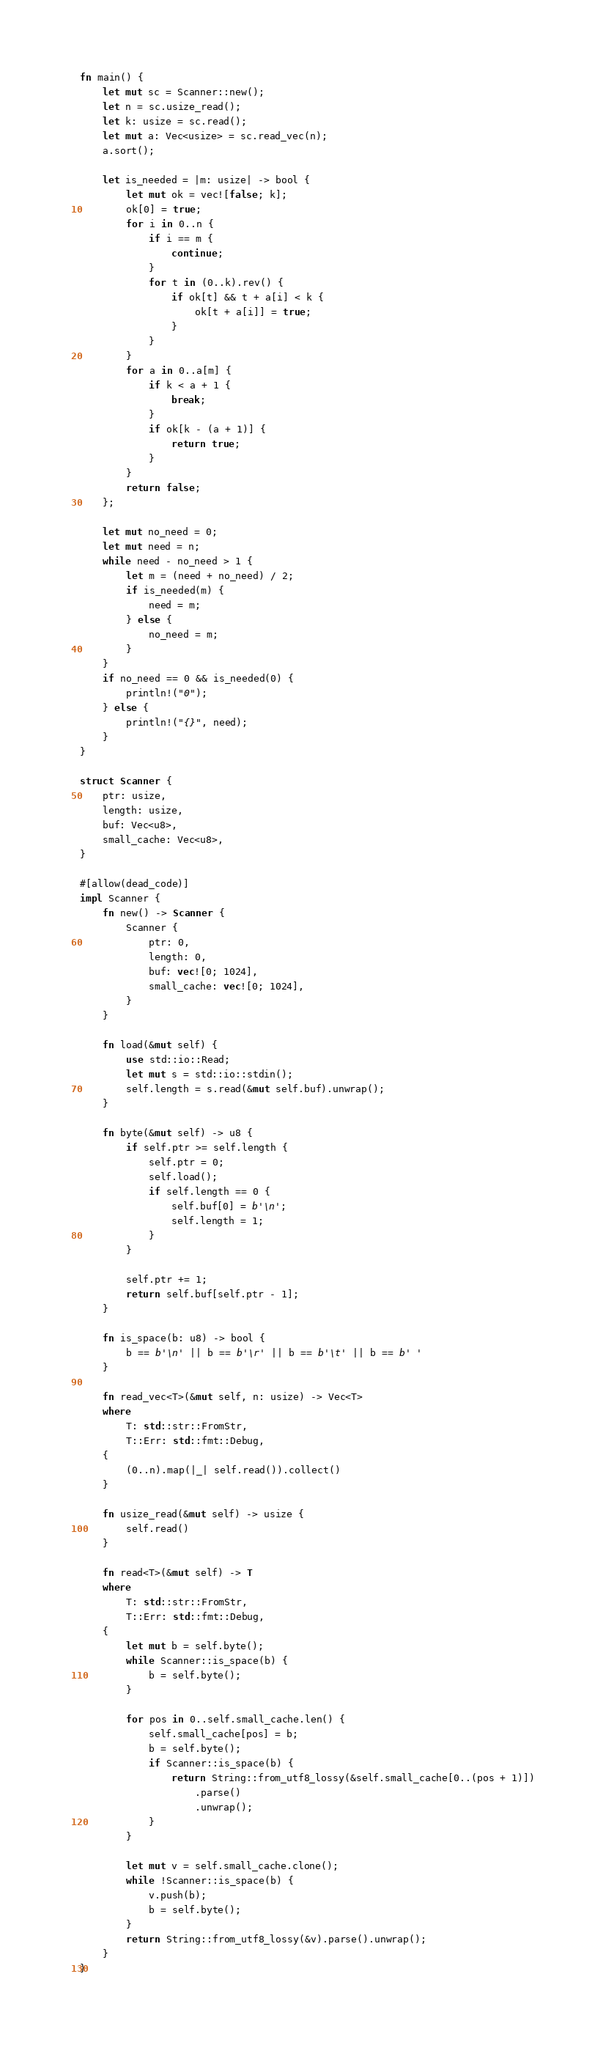<code> <loc_0><loc_0><loc_500><loc_500><_Rust_>fn main() {
    let mut sc = Scanner::new();
    let n = sc.usize_read();
    let k: usize = sc.read();
    let mut a: Vec<usize> = sc.read_vec(n);
    a.sort();

    let is_needed = |m: usize| -> bool {
        let mut ok = vec![false; k];
        ok[0] = true;
        for i in 0..n {
            if i == m {
                continue;
            }
            for t in (0..k).rev() {
                if ok[t] && t + a[i] < k {
                    ok[t + a[i]] = true;
                }
            }
        }
        for a in 0..a[m] {
            if k < a + 1 {
                break;
            }
            if ok[k - (a + 1)] {
                return true;
            }
        }
        return false;
    };

    let mut no_need = 0;
    let mut need = n;
    while need - no_need > 1 {
        let m = (need + no_need) / 2;
        if is_needed(m) {
            need = m;
        } else {
            no_need = m;
        }
    }
    if no_need == 0 && is_needed(0) {
        println!("0");
    } else {
        println!("{}", need);
    }
}

struct Scanner {
    ptr: usize,
    length: usize,
    buf: Vec<u8>,
    small_cache: Vec<u8>,
}

#[allow(dead_code)]
impl Scanner {
    fn new() -> Scanner {
        Scanner {
            ptr: 0,
            length: 0,
            buf: vec![0; 1024],
            small_cache: vec![0; 1024],
        }
    }

    fn load(&mut self) {
        use std::io::Read;
        let mut s = std::io::stdin();
        self.length = s.read(&mut self.buf).unwrap();
    }

    fn byte(&mut self) -> u8 {
        if self.ptr >= self.length {
            self.ptr = 0;
            self.load();
            if self.length == 0 {
                self.buf[0] = b'\n';
                self.length = 1;
            }
        }

        self.ptr += 1;
        return self.buf[self.ptr - 1];
    }

    fn is_space(b: u8) -> bool {
        b == b'\n' || b == b'\r' || b == b'\t' || b == b' '
    }

    fn read_vec<T>(&mut self, n: usize) -> Vec<T>
    where
        T: std::str::FromStr,
        T::Err: std::fmt::Debug,
    {
        (0..n).map(|_| self.read()).collect()
    }

    fn usize_read(&mut self) -> usize {
        self.read()
    }

    fn read<T>(&mut self) -> T
    where
        T: std::str::FromStr,
        T::Err: std::fmt::Debug,
    {
        let mut b = self.byte();
        while Scanner::is_space(b) {
            b = self.byte();
        }

        for pos in 0..self.small_cache.len() {
            self.small_cache[pos] = b;
            b = self.byte();
            if Scanner::is_space(b) {
                return String::from_utf8_lossy(&self.small_cache[0..(pos + 1)])
                    .parse()
                    .unwrap();
            }
        }

        let mut v = self.small_cache.clone();
        while !Scanner::is_space(b) {
            v.push(b);
            b = self.byte();
        }
        return String::from_utf8_lossy(&v).parse().unwrap();
    }
}
</code> 